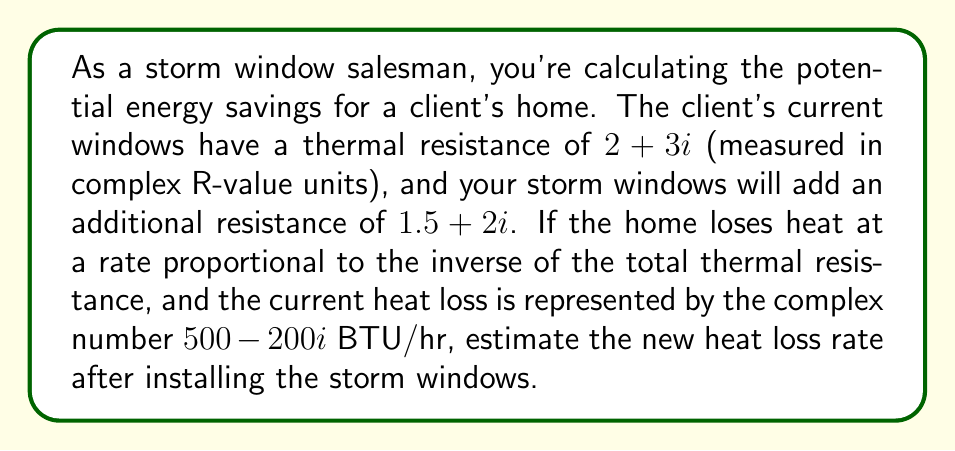Can you solve this math problem? To solve this problem, we'll follow these steps:

1) First, we need to calculate the total thermal resistance after adding the storm windows:
   $$(2 + 3i) + (1.5 + 2i) = 3.5 + 5i$$

2) The heat loss is inversely proportional to the thermal resistance. So we need to find the ratio of the old resistance to the new resistance:

   $$\frac{2 + 3i}{3.5 + 5i}$$

3) To divide complex numbers, we multiply by the complex conjugate of the denominator:

   $$\frac{2 + 3i}{3.5 + 5i} \cdot \frac{3.5 - 5i}{3.5 - 5i} = \frac{(2 + 3i)(3.5 - 5i)}{(3.5 + 5i)(3.5 - 5i)}$$

4) Expand the numerator:
   $$(2 + 3i)(3.5 - 5i) = 7 - 10i + 10.5i - 15i^2 = 7 + 0.5i + 15 = 22 + 0.5i$$

5) The denominator simplifies to:
   $$(3.5 + 5i)(3.5 - 5i) = 3.5^2 + 5^2 = 12.25 + 25 = 37.25$$

6) So our ratio is:
   $$\frac{22 + 0.5i}{37.25} = 0.59 + 0.013i$$

7) Now, to find the new heat loss, we multiply the current heat loss by this ratio:
   $$(500 - 200i)(0.59 + 0.013i) = 295 + 6.5i - 118i - 2.6i^2 = 297.6 - 111.5i$$

Therefore, the new heat loss rate is approximately $297.6 - 111.5i$ BTU/hr.
Answer: $297.6 - 111.5i$ BTU/hr 